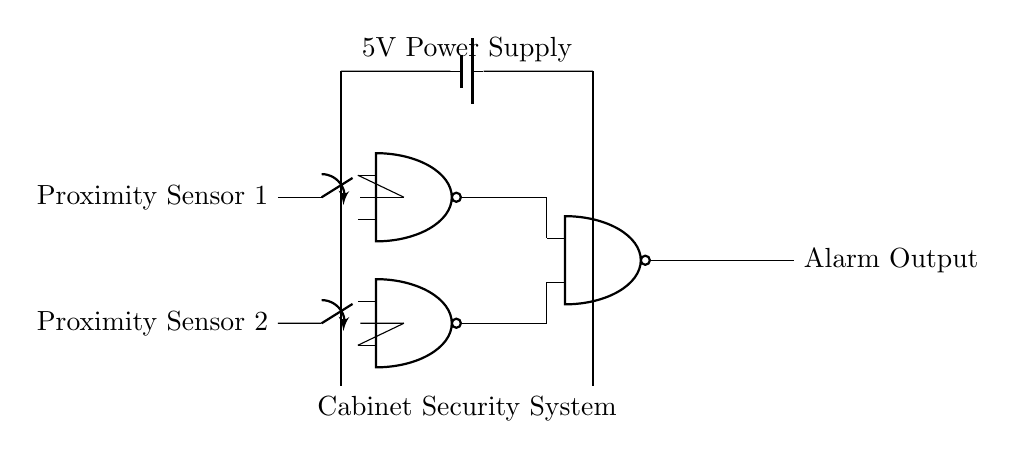What components are used in this circuit? The circuit includes two proximity sensors and three NAND gates. This information can be gathered by identifying the labels and symbols in the circuit diagram.
Answer: Proximity sensors, NAND gates What does the output signify in this circuit? The output signifies the alarm activation based on the conditions met by the NAND gates. The output line labeled "Alarm Output" connects to the last NAND gate, indicating it triggers when the inputs from the sensors and previous gates are processed.
Answer: Alarm Output How many NAND gates are present in the circuit? The circuit diagram shows three NAND gates. By counting the NAND port symbols in the diagram, we can determine the total number.
Answer: Three What happens when both proximity sensors are activated? When both proximity sensors are activated, both outputs from the first two NAND gates become low, leading the final NAND gate to output high, thus activating the alarm. The interaction of the inputs through the NAND logic determines this outcome.
Answer: Alarm activates What type of logic gate is primarily used in this circuit? The circuit primarily uses NAND gates for its operations, as evidenced by the symbols and their connections in the diagram. This suggests that the logic performed is based on NAND gate functionality.
Answer: NAND gates 